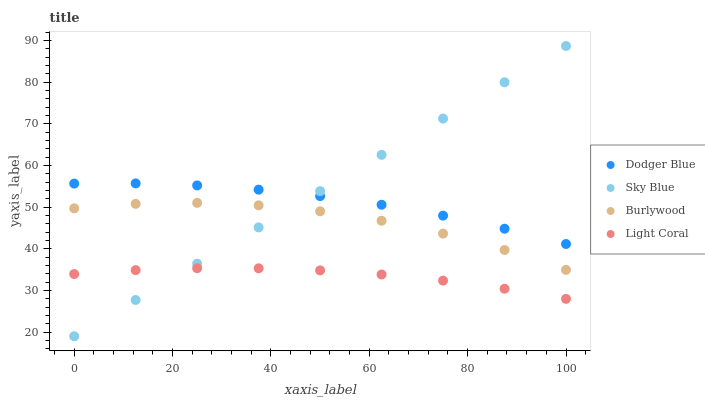Does Light Coral have the minimum area under the curve?
Answer yes or no. Yes. Does Sky Blue have the maximum area under the curve?
Answer yes or no. Yes. Does Dodger Blue have the minimum area under the curve?
Answer yes or no. No. Does Dodger Blue have the maximum area under the curve?
Answer yes or no. No. Is Sky Blue the smoothest?
Answer yes or no. Yes. Is Burlywood the roughest?
Answer yes or no. Yes. Is Dodger Blue the smoothest?
Answer yes or no. No. Is Dodger Blue the roughest?
Answer yes or no. No. Does Sky Blue have the lowest value?
Answer yes or no. Yes. Does Dodger Blue have the lowest value?
Answer yes or no. No. Does Sky Blue have the highest value?
Answer yes or no. Yes. Does Dodger Blue have the highest value?
Answer yes or no. No. Is Light Coral less than Burlywood?
Answer yes or no. Yes. Is Burlywood greater than Light Coral?
Answer yes or no. Yes. Does Dodger Blue intersect Sky Blue?
Answer yes or no. Yes. Is Dodger Blue less than Sky Blue?
Answer yes or no. No. Is Dodger Blue greater than Sky Blue?
Answer yes or no. No. Does Light Coral intersect Burlywood?
Answer yes or no. No. 